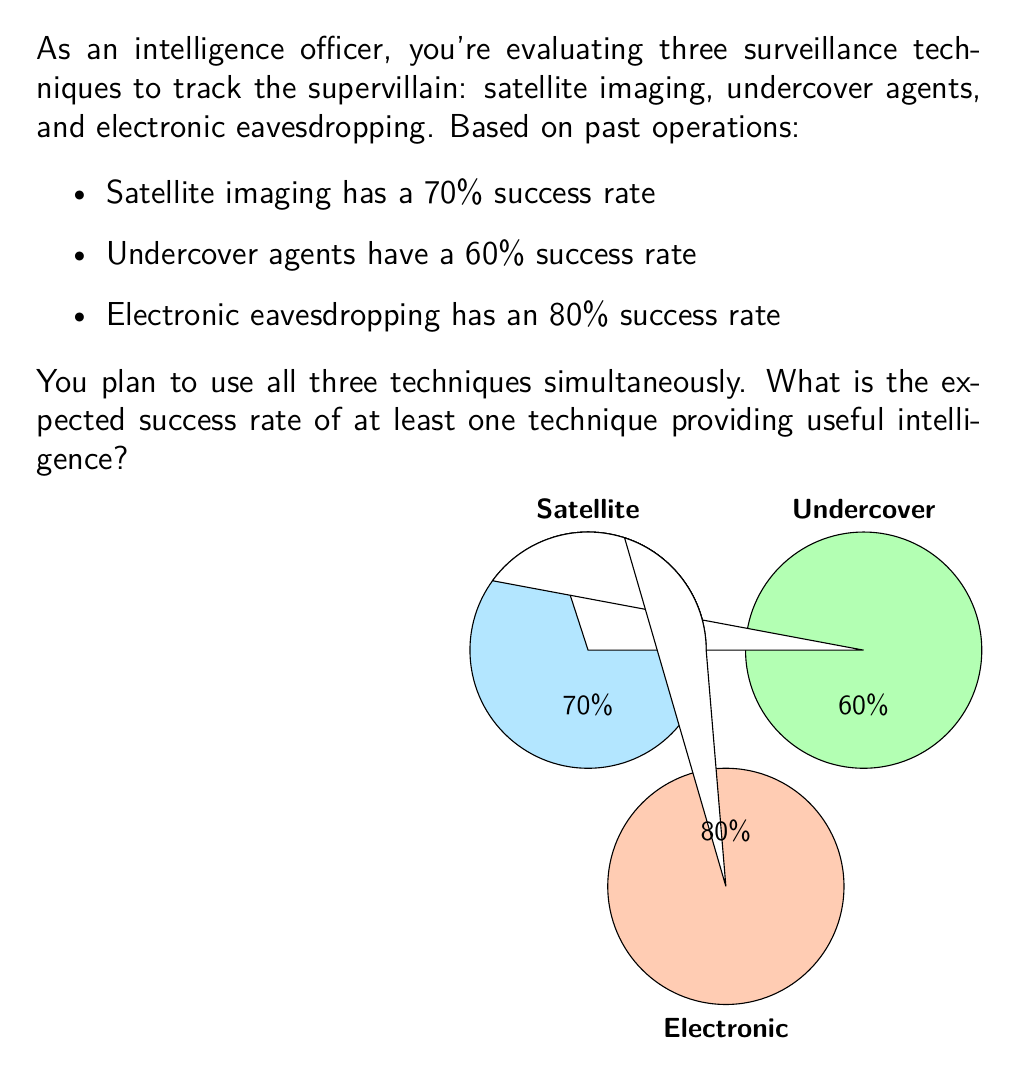What is the answer to this math problem? To solve this problem, we'll use the concept of probability of at least one event occurring, which is the complement of the probability that none of the events occur.

Let's approach this step-by-step:

1) First, let's calculate the probability of each technique failing:
   - Satellite imaging: $1 - 0.70 = 0.30$ or 30%
   - Undercover agents: $1 - 0.60 = 0.40$ or 40%
   - Electronic eavesdropping: $1 - 0.80 = 0.20$ or 20%

2) The probability of all techniques failing simultaneously is the product of their individual failure probabilities:

   $$P(\text{all fail}) = 0.30 \times 0.40 \times 0.20 = 0.024 \text{ or } 2.4\%$$

3) The probability of at least one technique succeeding is the complement of all failing:

   $$P(\text{at least one succeeds}) = 1 - P(\text{all fail})$$
   $$= 1 - 0.024 = 0.976$$

4) Convert to a percentage:

   $$0.976 \times 100\% = 97.6\%$$

Therefore, the expected success rate of at least one technique providing useful intelligence is 97.6%.
Answer: 97.6% 